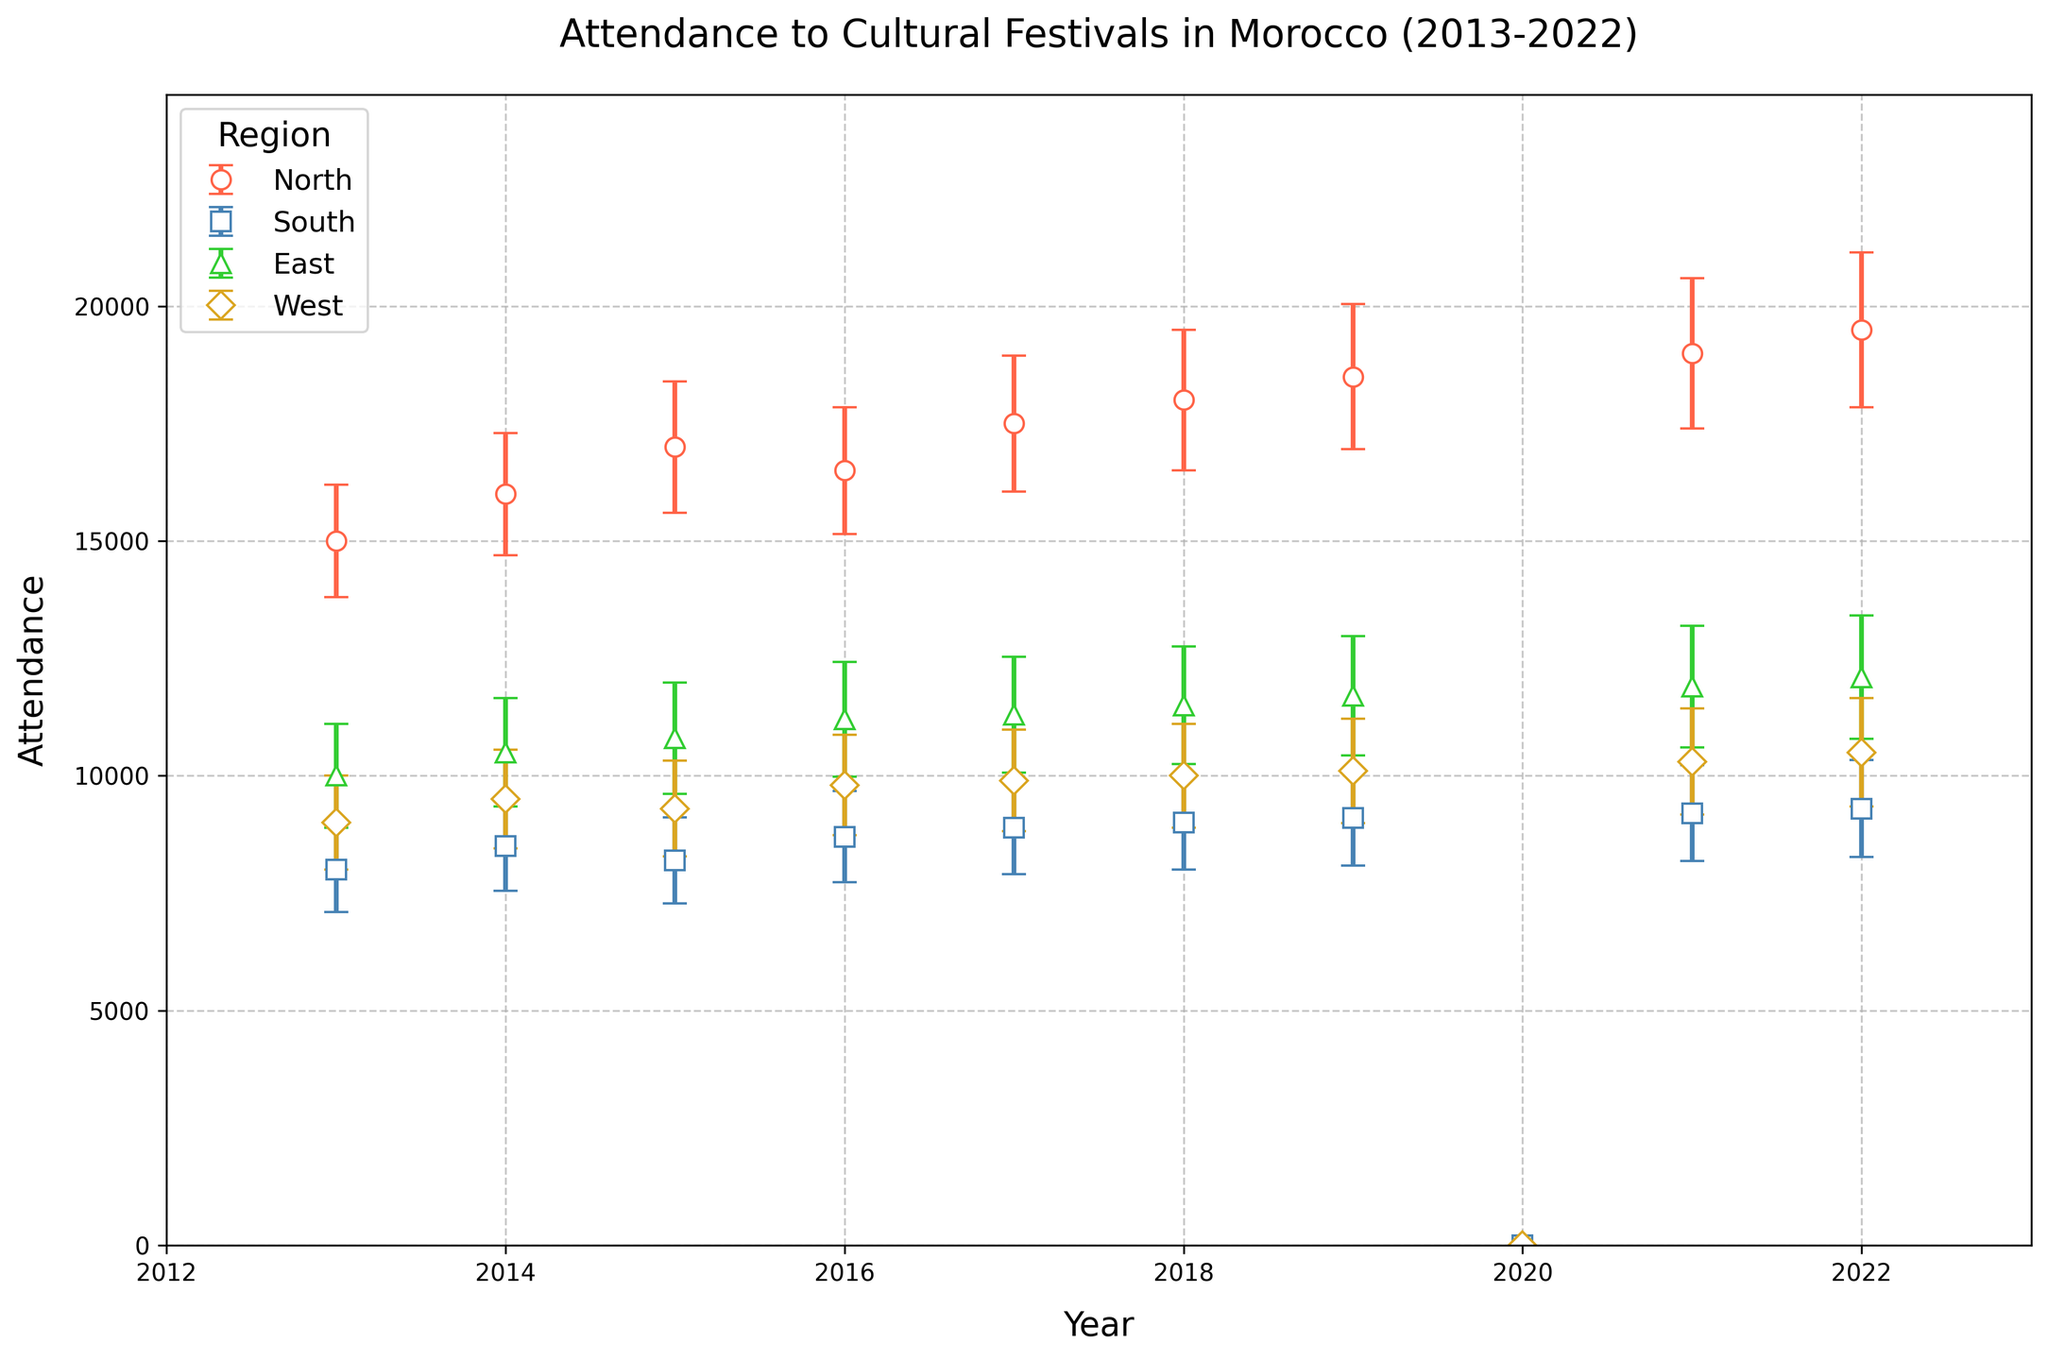Which region had the highest attendance in 2022? The region with the highest attendance in 2022 can be identified by looking for the tallest marker at the year 2022 on the x-axis. The North region had the highest attendance with 19,500 attendees.
Answer: North Why is there a drop in attendance for all regions in 2020? All regions show zero attendance in 2020. This can be inferred to be due to an exceptional event affecting all regions equally, likely the COVID-19 pandemic.
Answer: COVID-19 pandemic How did the attendance in the South region change from 2013 to 2022? To find the change in attendance from 2013 to 2022 for the South region, subtract the attendance in 2013 (8,000) from the attendance in 2022 (9,300). The difference is 1,300.
Answer: Increased by 1,300 Which year saw the least attendance overall, excluding 2020? Excluding 2020, we look for the year with the shortest markers overall. In this case, 2013 saw the least attendance with the total being 42,000 (sum of all regions).
Answer: 2013 By how much did the attendance in the East region increase from 2018 to 2022? Compute the difference between the attendance in 2018 (11,500) and 2022 (12,100). The increase is 600.
Answer: Increased by 600 Which region experienced the smallest variation in attendance over the decade? To determine the smallest variation, observe the error bars’ sizes for each region. The South region consistently exhibits smaller error bars across the years, implying less variation.
Answer: South What visual indicator represents the error margin for attendance in each region? The figure uses error bars to indicate the error margin. These bars extend vertically from the markers and indicate the uncertainty in attendance numbers.
Answer: Error bars How does the attendance trend in the North region compare to that of the West region? Comparing both trends: North’s attendance steadily increases over time despite a drop in 2020, whereas the West region shows smaller, gradual increases.
Answer: North had a steadier increase How many regions had an attendance increase every year (excluding 2020) from 2013 to 2022? Examine the markers for each region across the years. The East and North regions show a continual increase in attendance each year, excluding the drop in 2020.
Answer: 2 regions What was the difference in attendance between the North and West regions in 2021? Calculate the attendance for the North (19,000) and West (10,300) regions in 2021. Subtract West's attendance from North's attendance: 19,000 - 10,300 = 8,700.
Answer: 8,700 